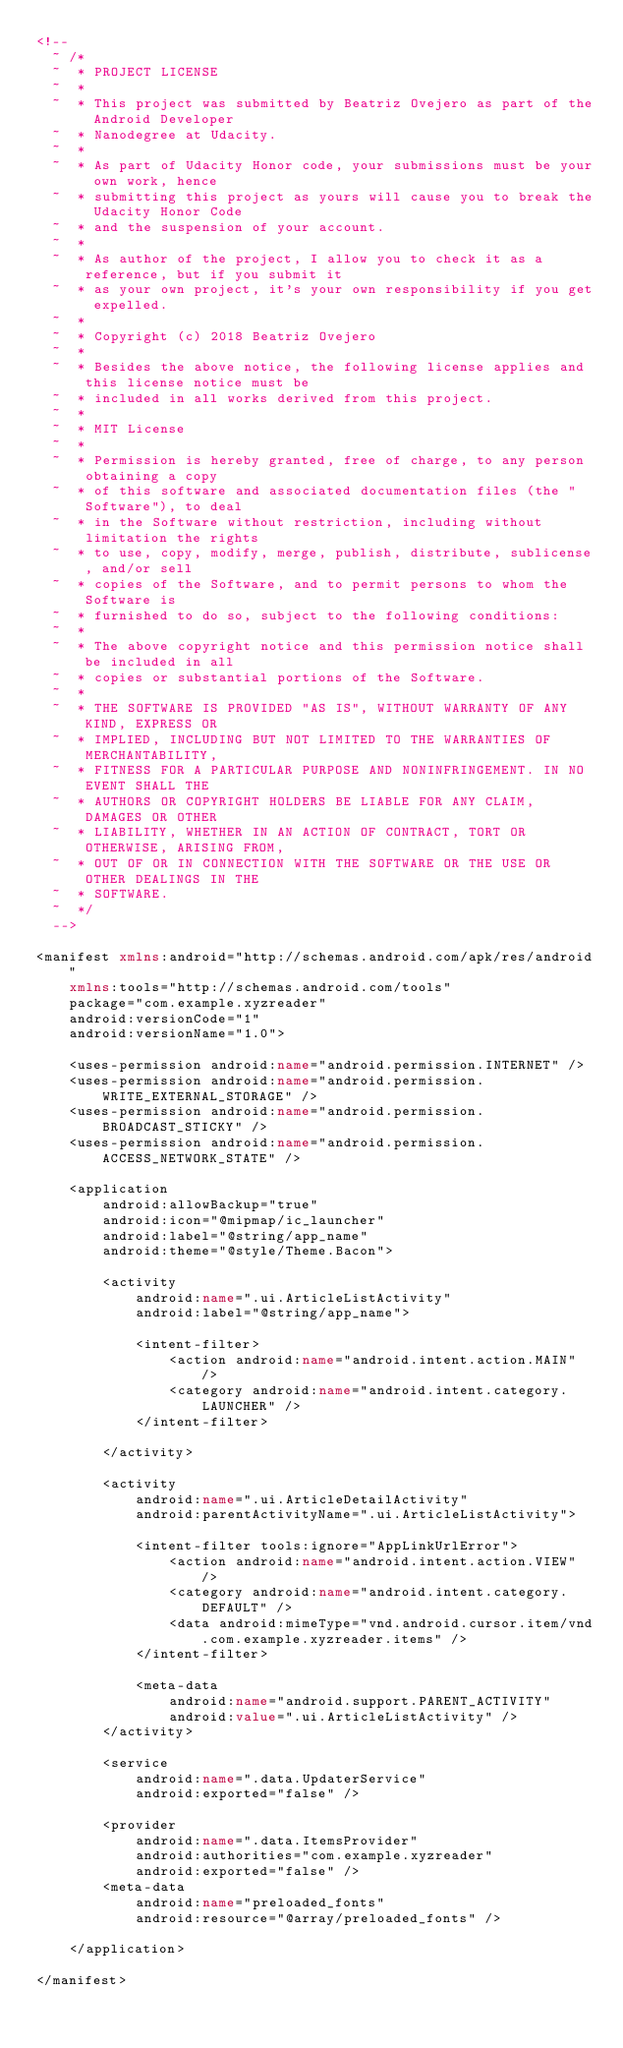<code> <loc_0><loc_0><loc_500><loc_500><_XML_><!--
  ~ /*
  ~  * PROJECT LICENSE
  ~  *
  ~  * This project was submitted by Beatriz Ovejero as part of the Android Developer
  ~  * Nanodegree at Udacity.
  ~  *
  ~  * As part of Udacity Honor code, your submissions must be your own work, hence
  ~  * submitting this project as yours will cause you to break the Udacity Honor Code
  ~  * and the suspension of your account.
  ~  *
  ~  * As author of the project, I allow you to check it as a reference, but if you submit it
  ~  * as your own project, it's your own responsibility if you get expelled.
  ~  *
  ~  * Copyright (c) 2018 Beatriz Ovejero
  ~  *
  ~  * Besides the above notice, the following license applies and this license notice must be
  ~  * included in all works derived from this project.
  ~  *
  ~  * MIT License
  ~  *
  ~  * Permission is hereby granted, free of charge, to any person obtaining a copy
  ~  * of this software and associated documentation files (the "Software"), to deal
  ~  * in the Software without restriction, including without limitation the rights
  ~  * to use, copy, modify, merge, publish, distribute, sublicense, and/or sell
  ~  * copies of the Software, and to permit persons to whom the Software is
  ~  * furnished to do so, subject to the following conditions:
  ~  *
  ~  * The above copyright notice and this permission notice shall be included in all
  ~  * copies or substantial portions of the Software.
  ~  *
  ~  * THE SOFTWARE IS PROVIDED "AS IS", WITHOUT WARRANTY OF ANY KIND, EXPRESS OR
  ~  * IMPLIED, INCLUDING BUT NOT LIMITED TO THE WARRANTIES OF MERCHANTABILITY,
  ~  * FITNESS FOR A PARTICULAR PURPOSE AND NONINFRINGEMENT. IN NO EVENT SHALL THE
  ~  * AUTHORS OR COPYRIGHT HOLDERS BE LIABLE FOR ANY CLAIM, DAMAGES OR OTHER
  ~  * LIABILITY, WHETHER IN AN ACTION OF CONTRACT, TORT OR OTHERWISE, ARISING FROM,
  ~  * OUT OF OR IN CONNECTION WITH THE SOFTWARE OR THE USE OR OTHER DEALINGS IN THE
  ~  * SOFTWARE.
  ~  */
  -->

<manifest xmlns:android="http://schemas.android.com/apk/res/android"
    xmlns:tools="http://schemas.android.com/tools"
    package="com.example.xyzreader"
    android:versionCode="1"
    android:versionName="1.0">

    <uses-permission android:name="android.permission.INTERNET" />
    <uses-permission android:name="android.permission.WRITE_EXTERNAL_STORAGE" />
    <uses-permission android:name="android.permission.BROADCAST_STICKY" />
    <uses-permission android:name="android.permission.ACCESS_NETWORK_STATE" />

    <application
        android:allowBackup="true"
        android:icon="@mipmap/ic_launcher"
        android:label="@string/app_name"
        android:theme="@style/Theme.Bacon">

        <activity
            android:name=".ui.ArticleListActivity"
            android:label="@string/app_name">

            <intent-filter>
                <action android:name="android.intent.action.MAIN" />
                <category android:name="android.intent.category.LAUNCHER" />
            </intent-filter>

        </activity>

        <activity
            android:name=".ui.ArticleDetailActivity"
            android:parentActivityName=".ui.ArticleListActivity">

            <intent-filter tools:ignore="AppLinkUrlError">
                <action android:name="android.intent.action.VIEW" />
                <category android:name="android.intent.category.DEFAULT" />
                <data android:mimeType="vnd.android.cursor.item/vnd.com.example.xyzreader.items" />
            </intent-filter>

            <meta-data
                android:name="android.support.PARENT_ACTIVITY"
                android:value=".ui.ArticleListActivity" />
        </activity>

        <service
            android:name=".data.UpdaterService"
            android:exported="false" />

        <provider
            android:name=".data.ItemsProvider"
            android:authorities="com.example.xyzreader"
            android:exported="false" />
        <meta-data
            android:name="preloaded_fonts"
            android:resource="@array/preloaded_fonts" />

    </application>

</manifest>
</code> 